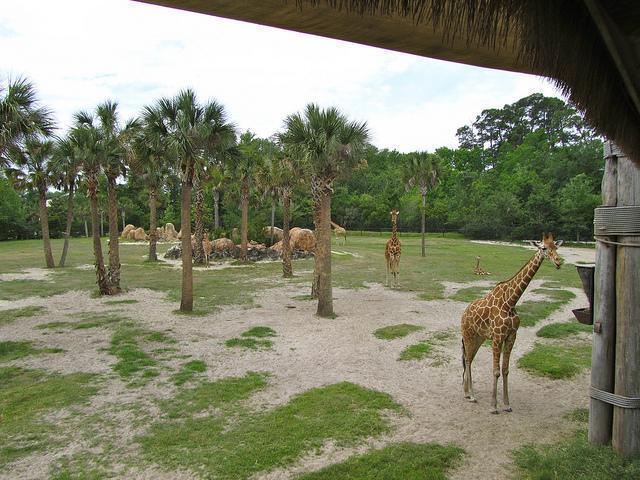What kind of structure is the animal all the way to the right looking at?
Answer the question by selecting the correct answer among the 4 following choices.
Options: Diamond, wooden, brick, mud. Wooden. 